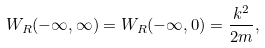<formula> <loc_0><loc_0><loc_500><loc_500>W _ { R } ( - \infty , \infty ) = W _ { R } ( - \infty , 0 ) = \frac { k ^ { 2 } } { 2 m } ,</formula> 